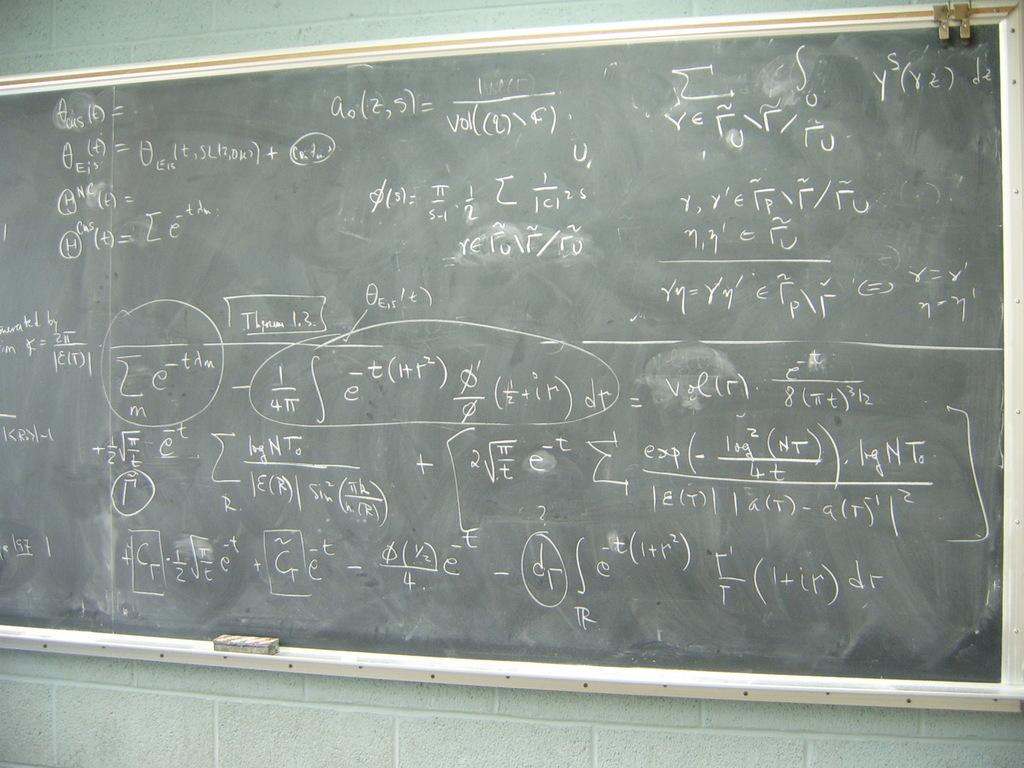<image>
Give a short and clear explanation of the subsequent image. A chalkboard filled with equations as the letter e multiple times. 